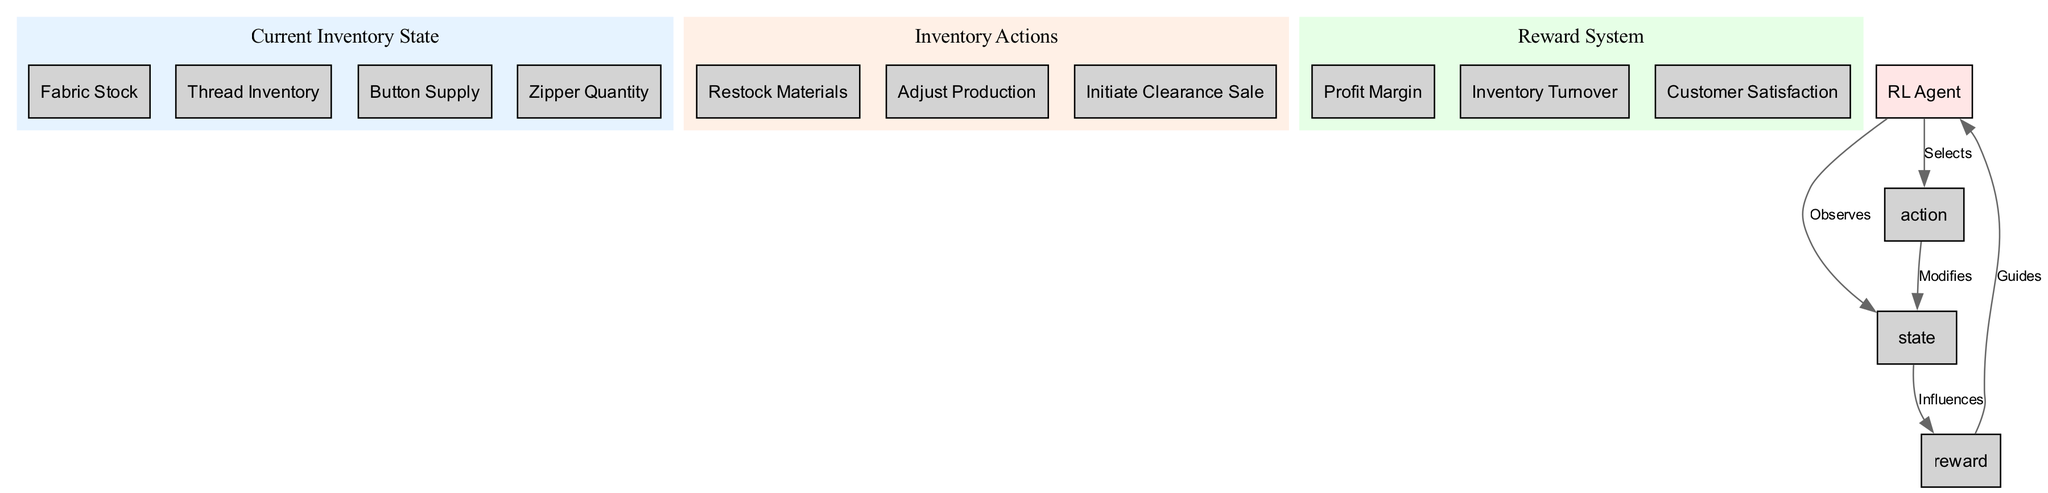What is the label of the node representing the current inventory state? The node labeled as "Current Inventory State" signifies the overall status of inventory, and it can be found as a node in the diagram.
Answer: Current Inventory State How many types of inventory actions are there? There are three action types shown as children under the node labeled "Inventory Actions," which include "Restock Materials," "Adjust Production," and "Initiate Clearance Sale."
Answer: 3 Which element influences the reward system? The "Current Inventory State" node directly influences the "Reward System" in the diagram, as indicated by the edge connecting these nodes.
Answer: Current Inventory State What guides the RL agent in making decisions? The "Reward System" guides the RL agent by providing feedback on the outcomes of actions taken, which is evident from the directed edge that leads from the reward node to the agent node.
Answer: Reward System Describe the relationship between the action "restock" and the inventory state. The action "Restock Materials" modifies the current inventory state by increasing the stock levels, as illustrated by the directed edge connecting the action to the state.
Answer: Modifies What are the components of the reward system? The reward system consists of three components: "Profit Margin," "Inventory Turnover," and "Customer Satisfaction," which are listed under the "Reward System" node.
Answer: Profit Margin, Inventory Turnover, Customer Satisfaction How does the RL agent interact with the state and action nodes? The RL agent first observes the current inventory state and then selects one of the inventory actions based on its observations, which is shown in the diagram by the directed edges leading from the agent to both state and action nodes.
Answer: Observes and Selects What is the overall flow from the RL agent to the reward system? The flow begins with the RL agent observing the current inventory state, selecting an action that modifies that state, which then influences the reward system, and finally receives guidance from the rewards for future decisions.
Answer: Observes, Selects, Modifies, Influences, Guides 